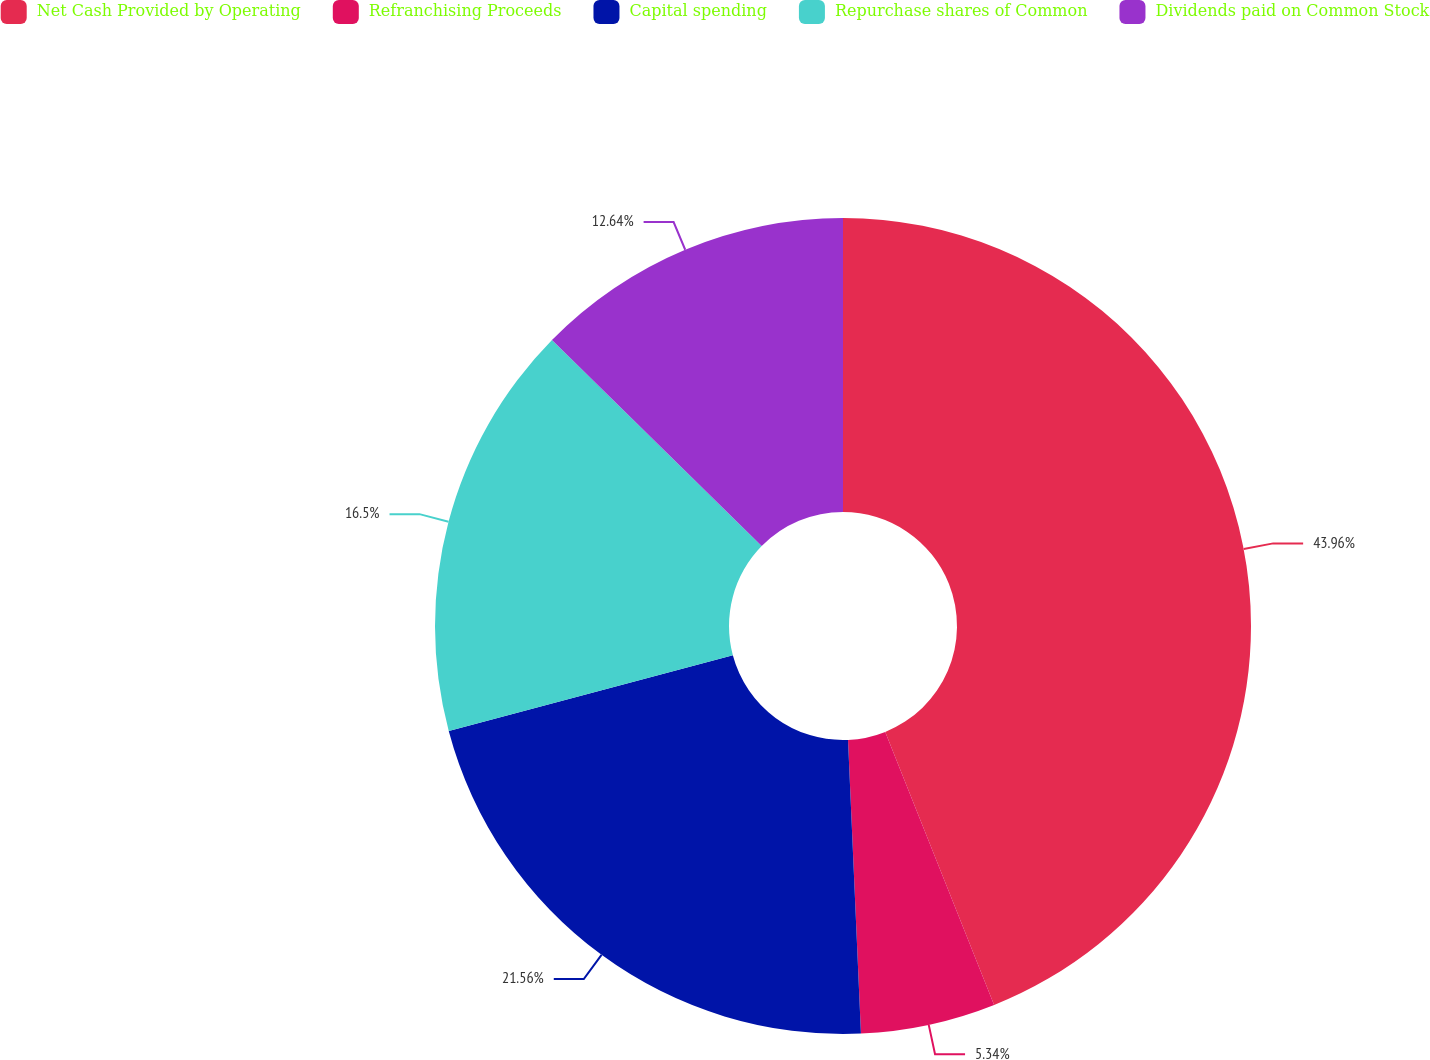Convert chart. <chart><loc_0><loc_0><loc_500><loc_500><pie_chart><fcel>Net Cash Provided by Operating<fcel>Refranchising Proceeds<fcel>Capital spending<fcel>Repurchase shares of Common<fcel>Dividends paid on Common Stock<nl><fcel>43.96%<fcel>5.34%<fcel>21.56%<fcel>16.5%<fcel>12.64%<nl></chart> 